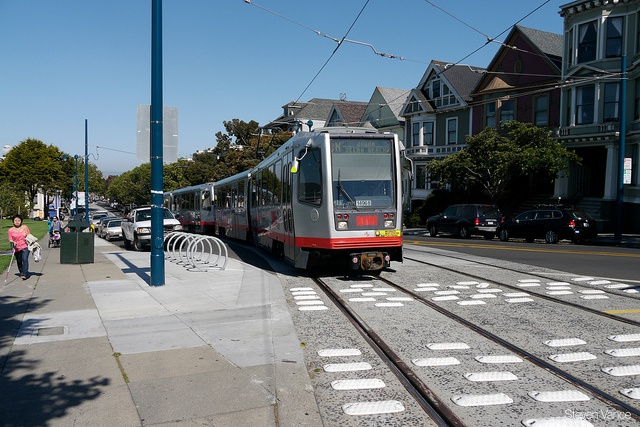Describe the objects in this image and their specific colors. I can see train in gray, black, and darkgray tones, car in gray, black, and darkgray tones, car in gray, black, and darkgray tones, truck in gray, black, lightgray, and darkgray tones, and people in gray, black, lightpink, salmon, and navy tones in this image. 